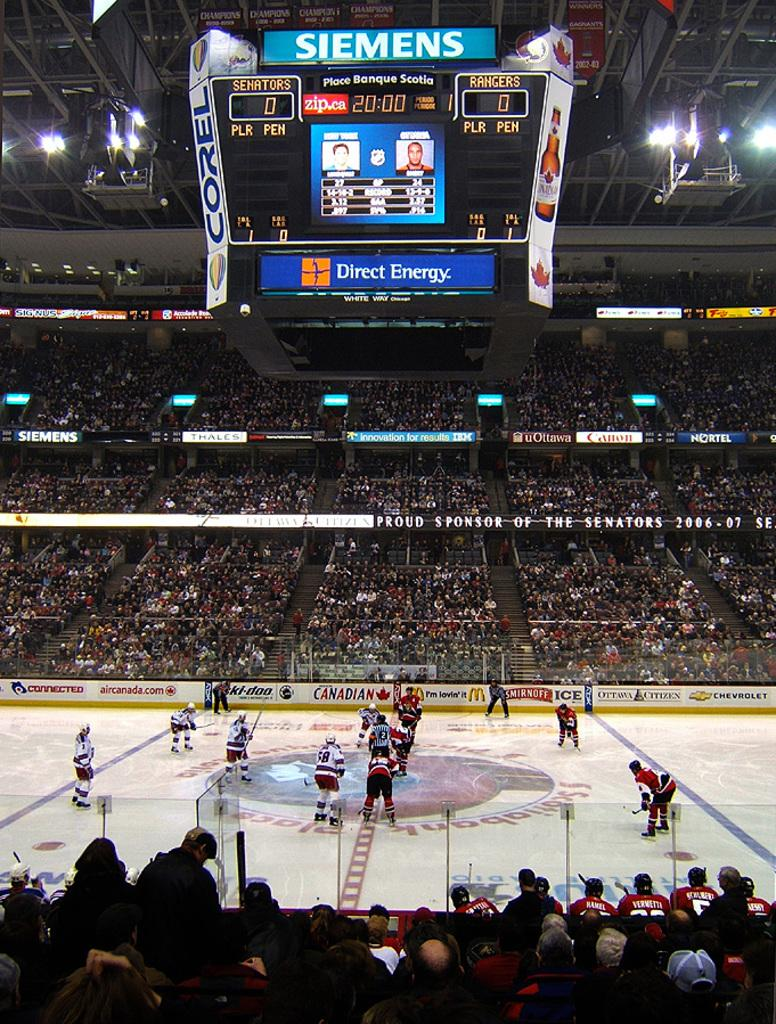<image>
Write a terse but informative summary of the picture. A hockey game that has a Siemens brand screen at the top. 